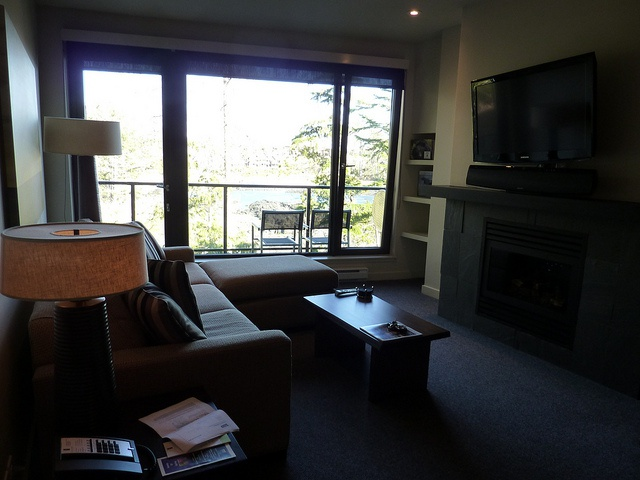Describe the objects in this image and their specific colors. I can see couch in black and gray tones, tv in black, darkgreen, and gray tones, couch in black, gray, and darkgray tones, chair in black, gray, ivory, and darkgray tones, and book in black and gray tones in this image. 